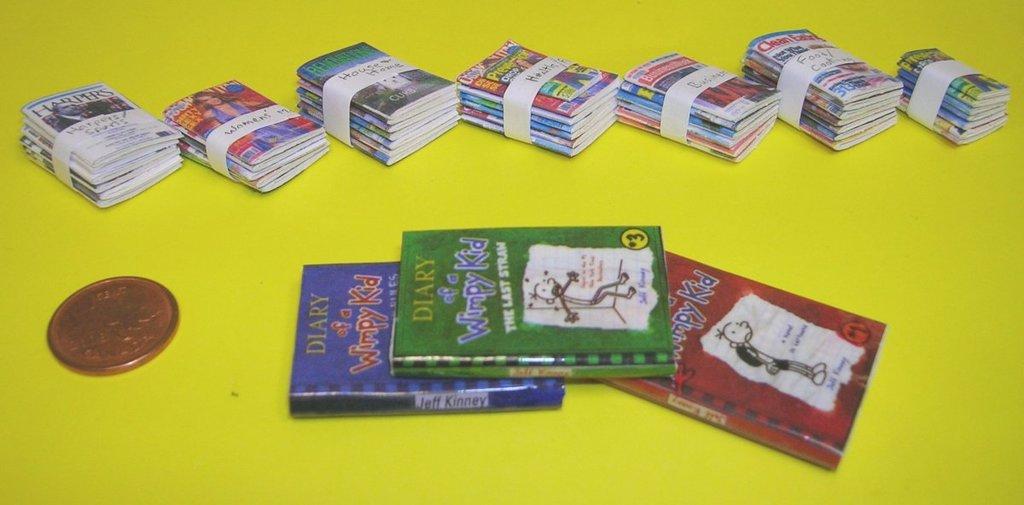What book series are these books a part of?
Offer a terse response. Diary of a wimpy kid. Who wrote these books?
Ensure brevity in your answer.  Jeff kinney. 